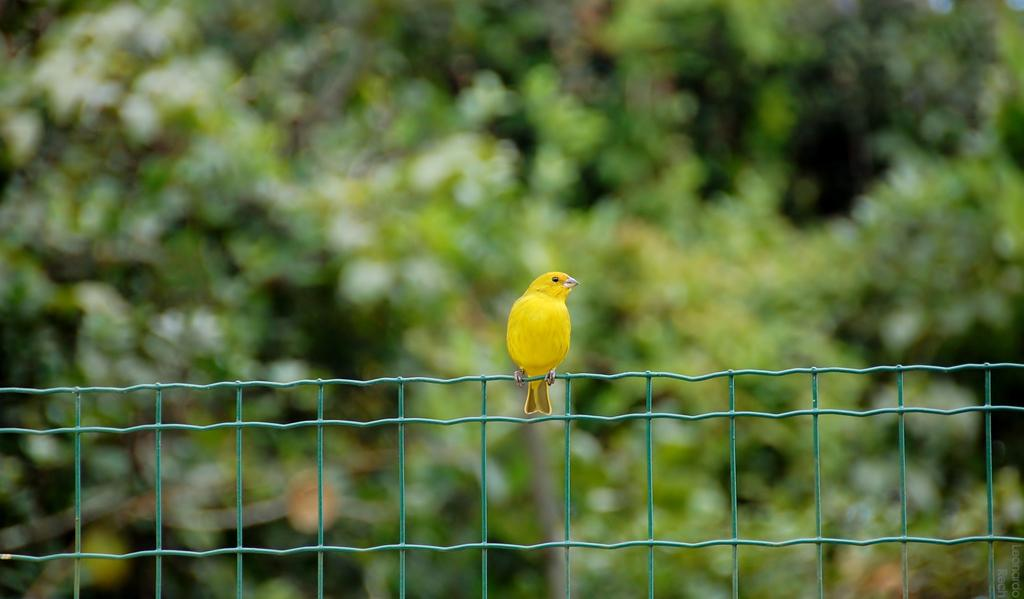What is on the metal fence in the image? There is a bird on the metal fence in the image. What can be seen in the background of the image? There are trees visible in the background of the image. What type of box is being used to protect the bird from the rain in the image? There is no box present in the image, and the bird is not being protected from the rain. 